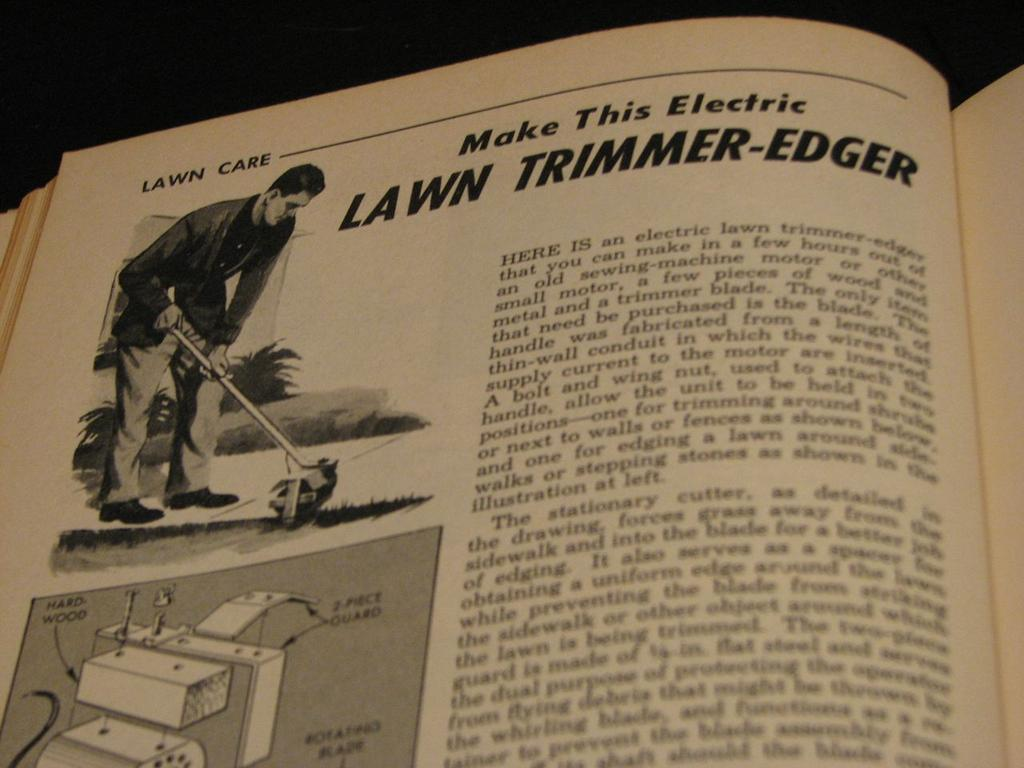<image>
Summarize the visual content of the image. An illustration of a man shows him using an electric lawn trimmer-edger. 